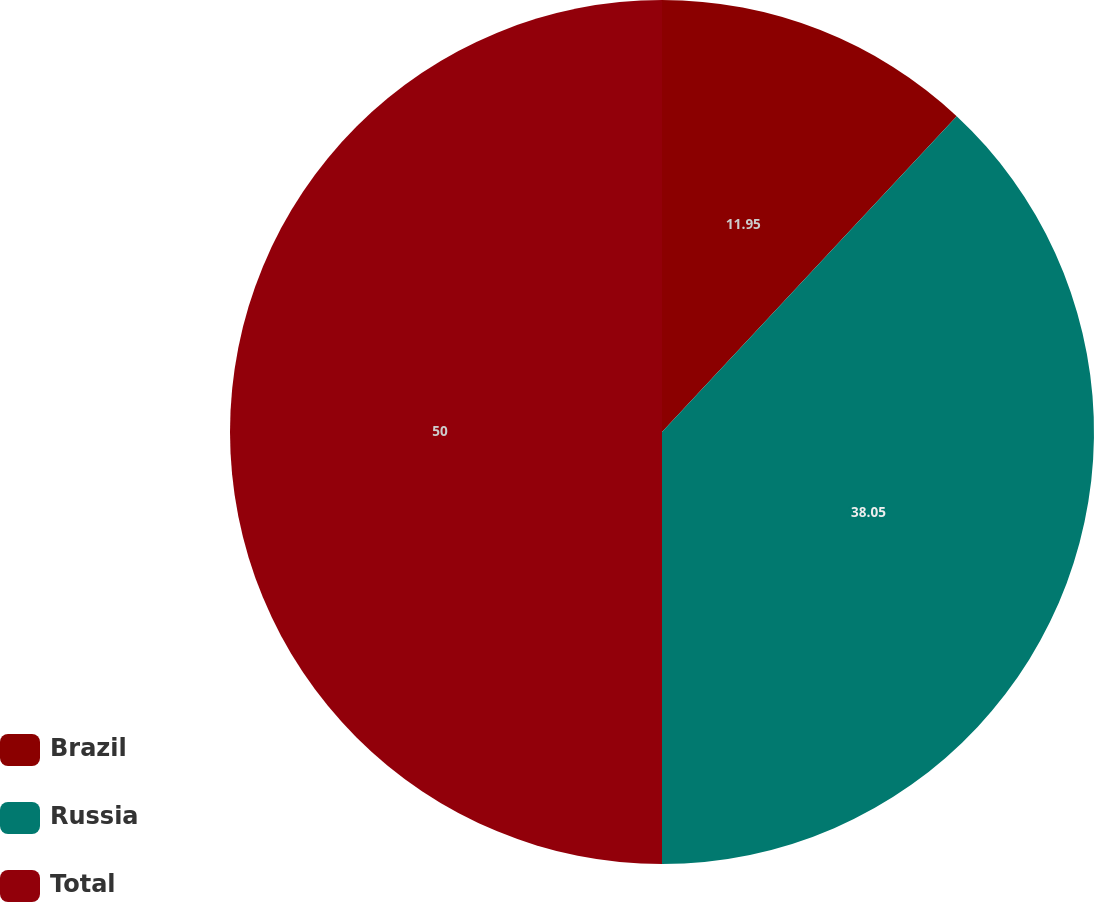<chart> <loc_0><loc_0><loc_500><loc_500><pie_chart><fcel>Brazil<fcel>Russia<fcel>Total<nl><fcel>11.95%<fcel>38.05%<fcel>50.0%<nl></chart> 